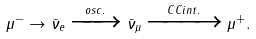<formula> <loc_0><loc_0><loc_500><loc_500>\mu ^ { - } \rightarrow \bar { \nu } _ { e } \xrightarrow { o s c . } \bar { \nu } _ { \mu } \xrightarrow { C C i n t . } \mu ^ { + } .</formula> 